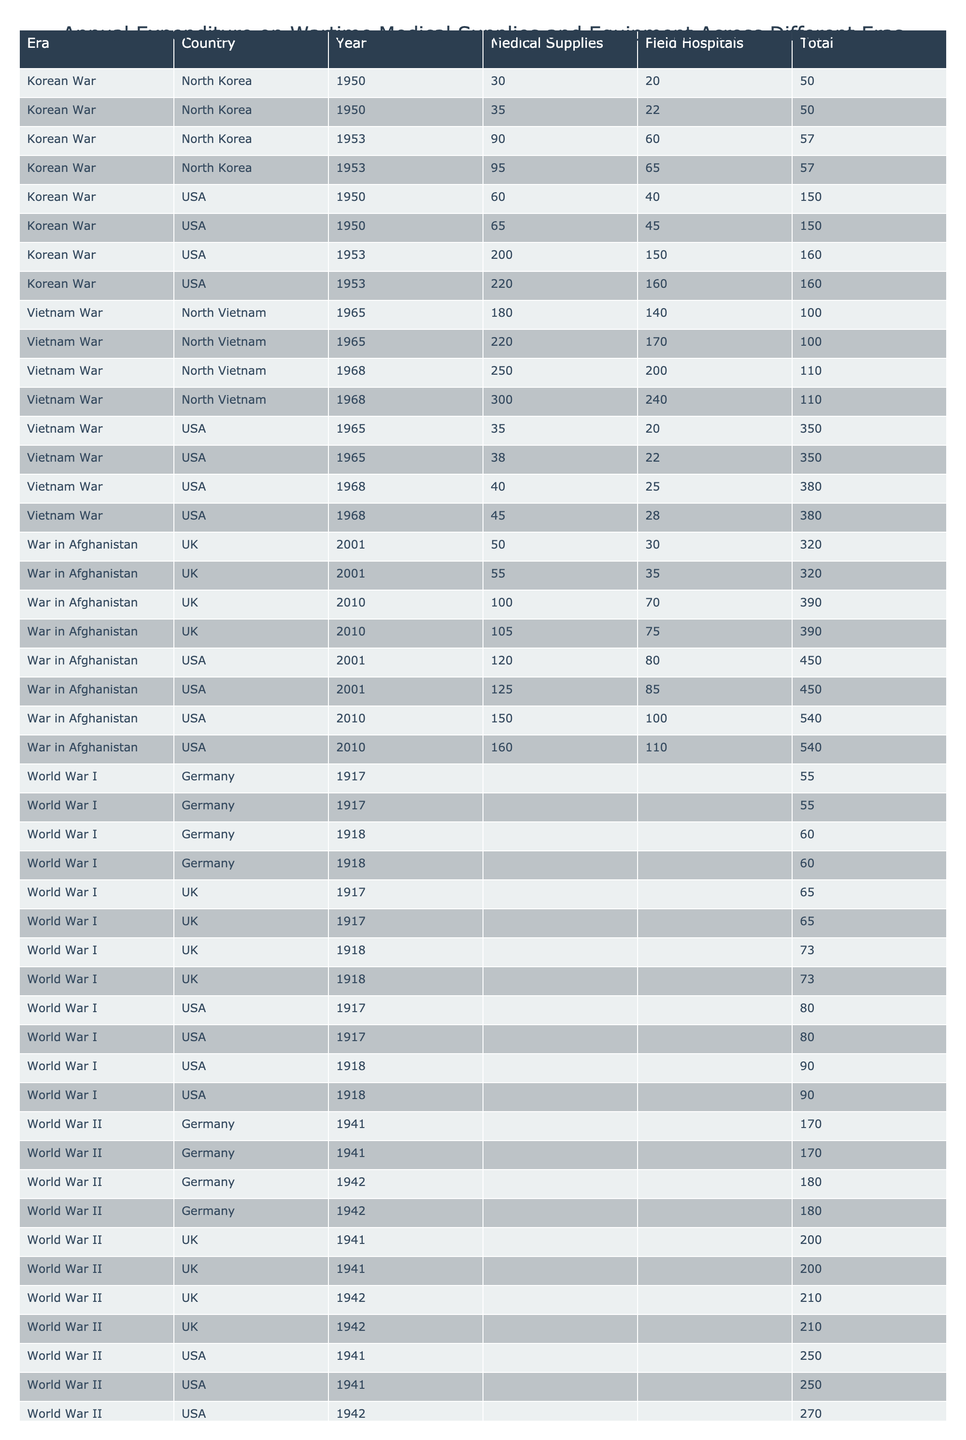What was the total expenditure on medical supplies by the USA in World War II? In World War II, the USA spent 150 million USD on medical supplies in 1941 and 160 million USD in 1942. Adding these amounts gives us a total expenditure of 150 + 160 = 310 million USD.
Answer: 310 million USD Which year saw the highest expenditure for field hospitals in the Vietnam War? In the Vietnam War, the USA spent 150 million USD on field hospitals in 1965 and 160 million USD in 1968. The higher amount in 1968 indicates that 1968 had the highest expenditure.
Answer: 1968 Did North Korea spend more on medical supplies in the Korean War than field hospitals? During the Korean War, North Korea spent 30 million USD on medical supplies and 20 million USD on field hospitals in 1950, and in 1953, they spent 35 million USD on medical supplies and 22 million USD on field hospitals. Summing these gives 30 + 35 = 65 million USD for medical supplies and 20 + 22 = 42 million USD for field hospitals. Since 65 million USD is greater than 42 million USD, the answer is yes.
Answer: Yes What was the average expenditure on field hospitals by the UK during the War in Afghanistan? The UK spent 140 million USD on field hospitals in 2001 and 170 million USD in 2010. Calculating the average involves adding these two amounts (140 + 170 = 310) and dividing by the number of entries (2), leading to an average of 310 / 2 = 155 million USD for field hospitals.
Answer: 155 million USD How much more did the USA spend on medical supplies in the Vietnam War compared to the Korean War? In the Vietnam War, the USA spent 200 million USD in 1965 and 220 million USD in 1968 on medical supplies, totaling 200 + 220 = 420 million USD. In the Korean War, they spent 90 million USD in 1950 and 95 million USD in 1953, totaling 90 + 95 = 185 million USD. The difference between the expenditures is 420 - 185 = 235 million USD.
Answer: 235 million USD 